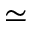Convert formula to latex. <formula><loc_0><loc_0><loc_500><loc_500>\simeq</formula> 